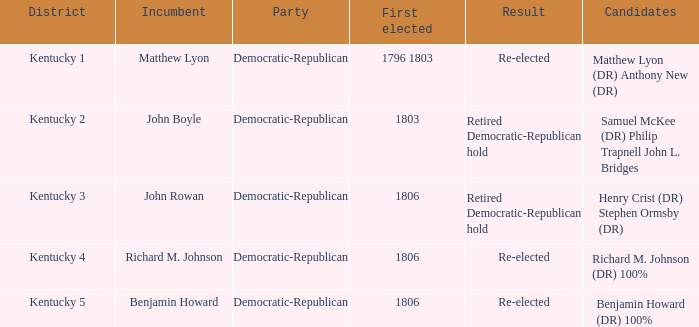Identify the initial individual elected to represent kentucky's 1st district. 1796 1803. 